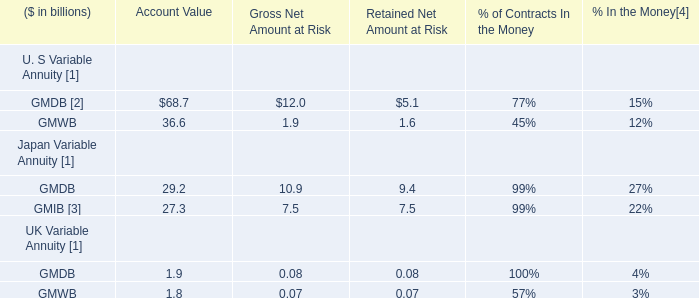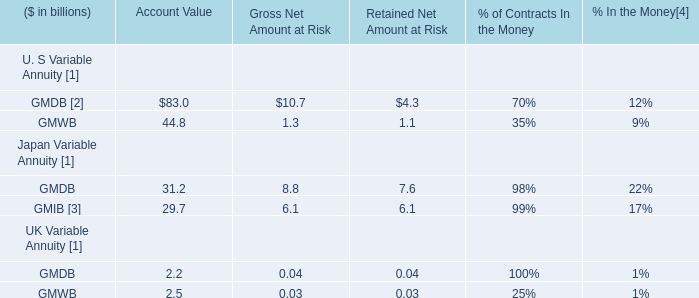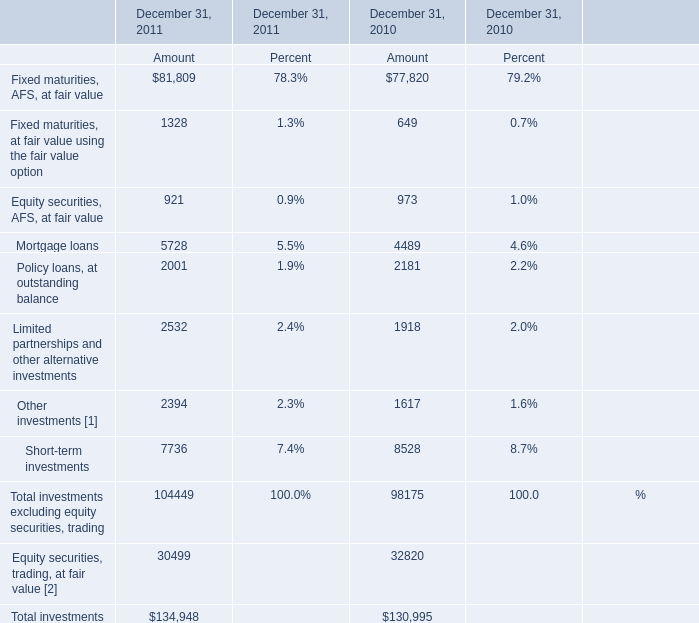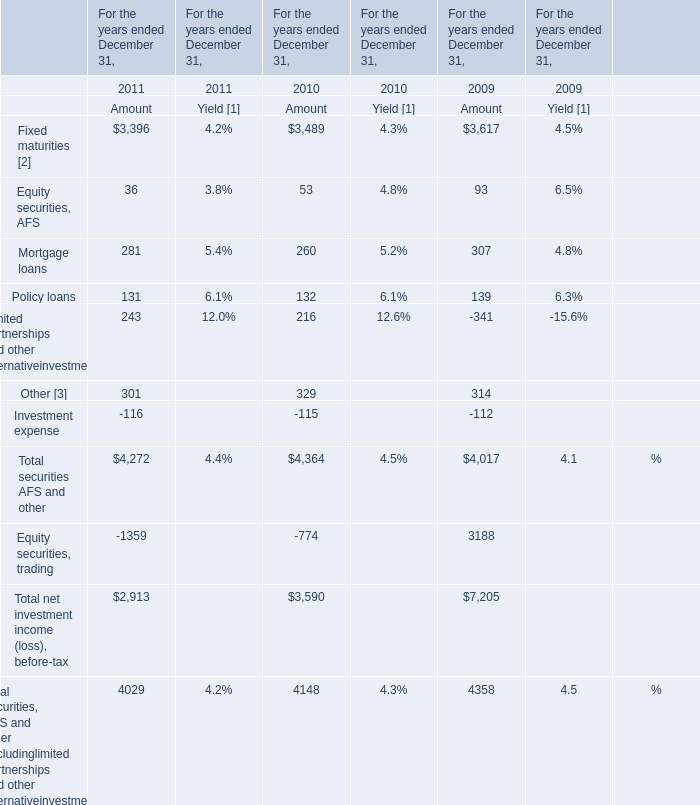In which year is Policy loans, at outstanding balance greater than Limited partnerships and other alternative investments for Amount? 
Answer: 2010. 